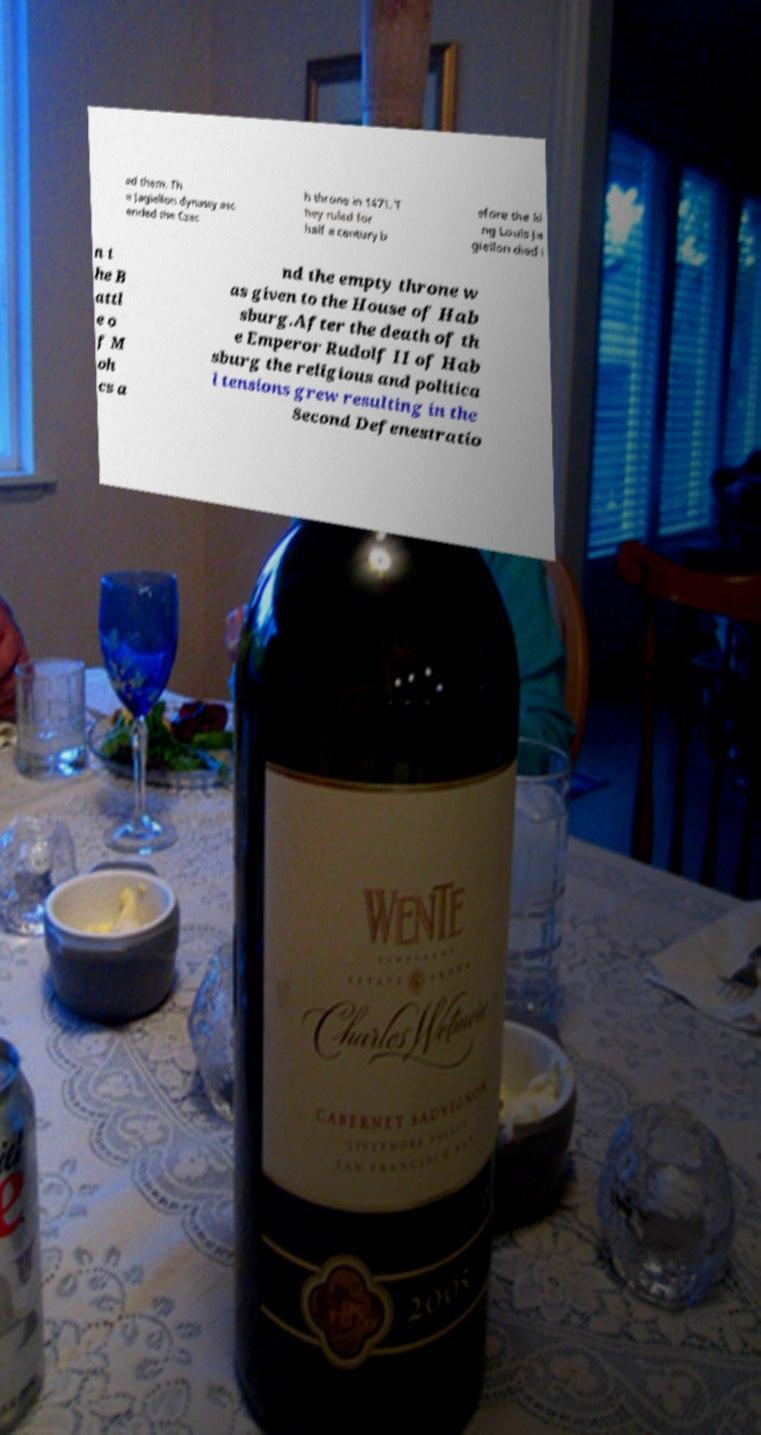Could you assist in decoding the text presented in this image and type it out clearly? ed them. Th e Jagiellon dynasty asc ended the Czec h throne in 1471. T hey ruled for half a century b efore the ki ng Louis Ja giellon died i n t he B attl e o f M oh cs a nd the empty throne w as given to the House of Hab sburg.After the death of th e Emperor Rudolf II of Hab sburg the religious and politica l tensions grew resulting in the Second Defenestratio 